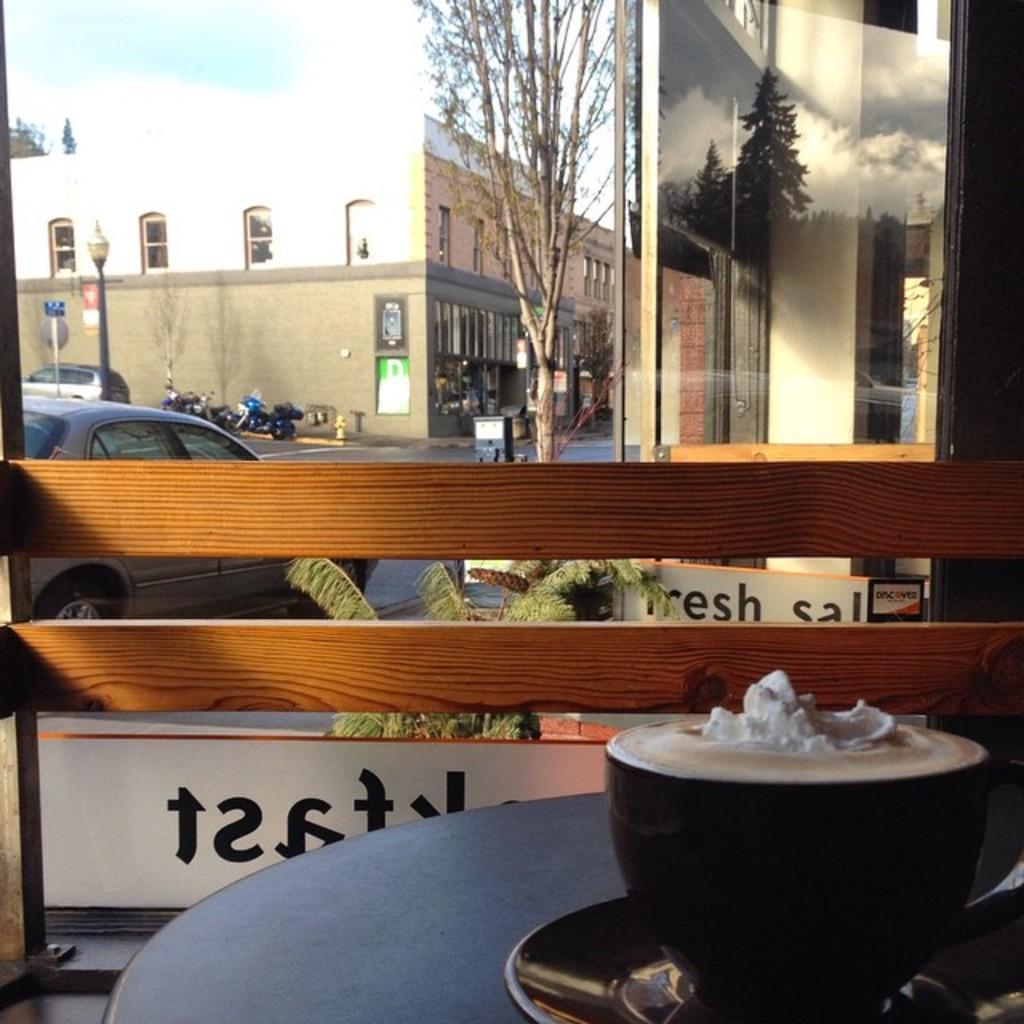Can you describe this image briefly? In this picture there is a table on which a bowl and a plate was placed. There is a wooden railing here. Through the window, we can observe some cars, buildings and a trees here. There is a sky and a clouds in the background. 